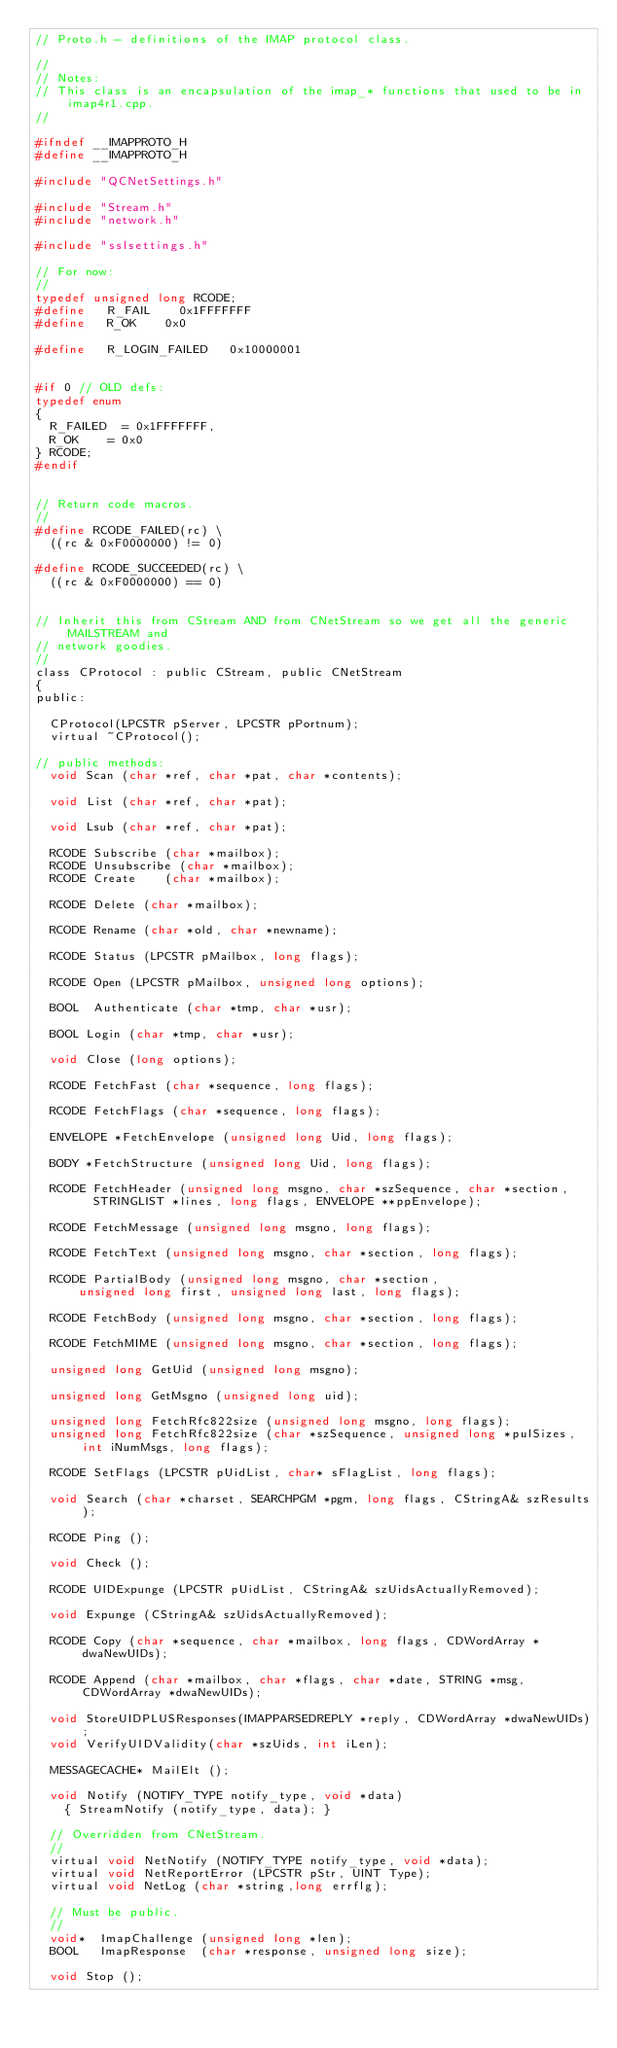Convert code to text. <code><loc_0><loc_0><loc_500><loc_500><_C_>// Proto.h - definitions of the IMAP protocol class.

//
// Notes:
// This class is an encapsulation of the imap_* functions that used to be in imap4r1.cpp.
//

#ifndef __IMAPPROTO_H
#define __IMAPPROTO_H

#include "QCNetSettings.h"

#include "Stream.h"
#include "network.h"

#include "sslsettings.h"

// For now:
//
typedef unsigned long RCODE;
#define 	R_FAIL		0x1FFFFFFF
#define 	R_OK		0x0

#define		R_LOGIN_FAILED   0x10000001


#if 0 // OLD defs:
typedef enum
{
 	R_FAILED	= 0x1FFFFFFF,
	R_OK		= 0x0
} RCODE;
#endif


// Return code macros.
//
#define RCODE_FAILED(rc) \
	((rc & 0xF0000000) != 0)

#define RCODE_SUCCEEDED(rc) \
	((rc & 0xF0000000) == 0)


// Inherit this from CStream AND from CNetStream so we get all the generic MAILSTREAM and
// network goodies.
//
class CProtocol : public CStream, public CNetStream
{
public:

	CProtocol(LPCSTR pServer, LPCSTR pPortnum);
	virtual ~CProtocol();

// public methods:
	void Scan (char *ref, char *pat, char *contents);

	void List (char *ref, char *pat);

	void Lsub (char *ref, char *pat);

	RCODE Subscribe	(char *mailbox);
	RCODE Unsubscribe (char *mailbox);
	RCODE Create		(char *mailbox);

	RCODE Delete (char *mailbox);

	RCODE Rename (char *old, char *newname);

	RCODE Status (LPCSTR pMailbox, long flags);

	RCODE Open (LPCSTR pMailbox, unsigned long options);

	BOOL  Authenticate (char *tmp, char *usr);

	BOOL Login (char *tmp, char *usr);

	void Close (long options);

	RCODE FetchFast (char *sequence, long flags);

	RCODE FetchFlags (char *sequence, long flags);

	ENVELOPE *FetchEnvelope (unsigned long Uid, long flags);

	BODY *FetchStructure (unsigned long Uid, long flags);

	RCODE FetchHeader (unsigned long msgno, char *szSequence, char *section,
				STRINGLIST *lines, long flags, ENVELOPE **ppEnvelope);

	RCODE FetchMessage (unsigned long msgno, long flags);

	RCODE FetchText (unsigned long msgno, char *section, long flags);

	RCODE PartialBody (unsigned long msgno, char *section,
			unsigned long first, unsigned long last, long flags);

	RCODE FetchBody (unsigned long msgno, char *section, long flags);

	RCODE FetchMIME (unsigned long msgno, char *section, long flags);

	unsigned long GetUid (unsigned long msgno);

	unsigned long GetMsgno (unsigned long uid);

	unsigned long FetchRfc822size (unsigned long msgno, long flags);
	unsigned long FetchRfc822size (char *szSequence, unsigned long *pulSizes, int iNumMsgs, long flags);

	RCODE SetFlags (LPCSTR pUidList, char* sFlagList, long flags);

	void Search (char *charset, SEARCHPGM *pgm, long flags, CStringA& szResults);

	RCODE Ping ();

	void Check ();

	RCODE	UIDExpunge (LPCSTR pUidList, CStringA& szUidsActuallyRemoved);

	void Expunge (CStringA& szUidsActuallyRemoved);

	RCODE Copy (char *sequence, char *mailbox, long flags, CDWordArray *dwaNewUIDs);

	RCODE Append (char *mailbox, char *flags, char *date, STRING *msg, CDWordArray *dwaNewUIDs);

	void StoreUIDPLUSResponses(IMAPPARSEDREPLY *reply, CDWordArray *dwaNewUIDs);
	void VerifyUIDValidity(char *szUids, int iLen);

	MESSAGECACHE* MailElt ();

	void Notify (NOTIFY_TYPE notify_type, void *data)
		{ StreamNotify (notify_type, data); }

	// Overridden from CNetStream.
	//
	virtual void NetNotify (NOTIFY_TYPE notify_type, void *data);
	virtual void NetReportError (LPCSTR pStr, UINT Type);
	virtual void NetLog	(char *string,long errflg);

	// Must be public.
	//
	void*  ImapChallenge (unsigned long *len);
	BOOL   ImapResponse  (char *response, unsigned long size);

	void Stop ();
</code> 